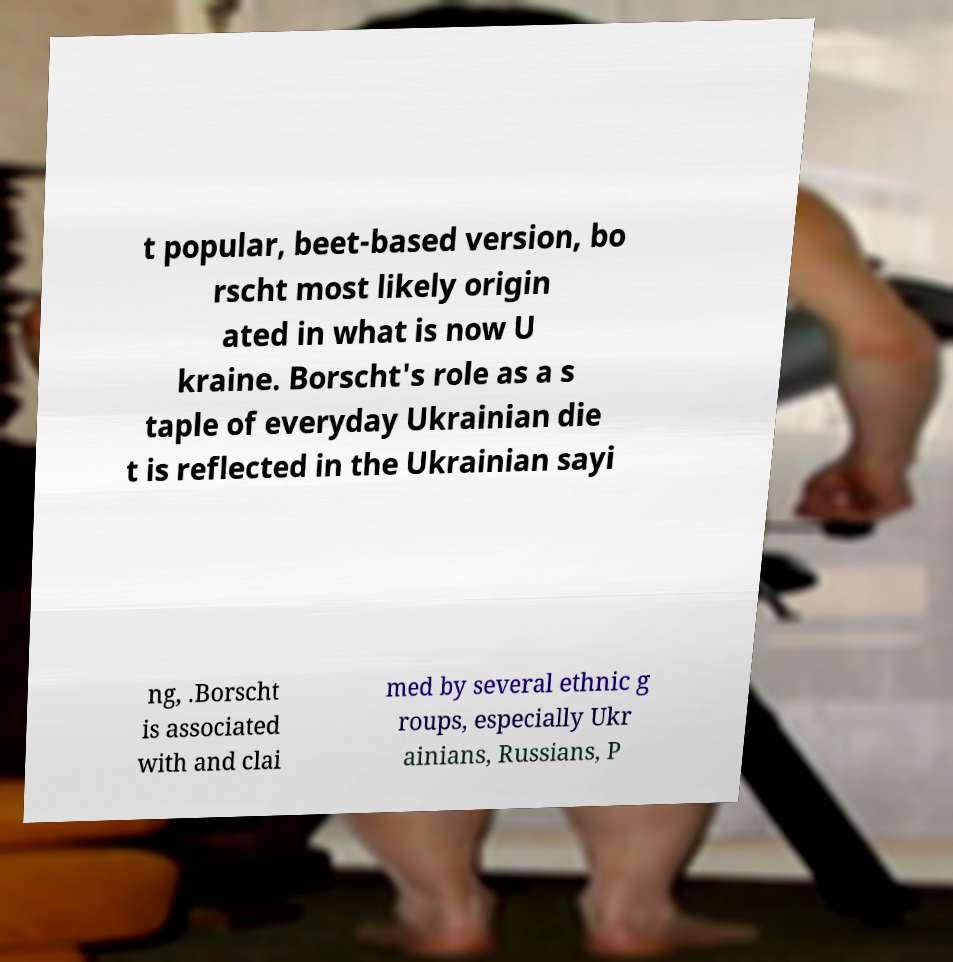Could you extract and type out the text from this image? t popular, beet-based version, bo rscht most likely origin ated in what is now U kraine. Borscht's role as a s taple of everyday Ukrainian die t is reflected in the Ukrainian sayi ng, .Borscht is associated with and clai med by several ethnic g roups, especially Ukr ainians, Russians, P 